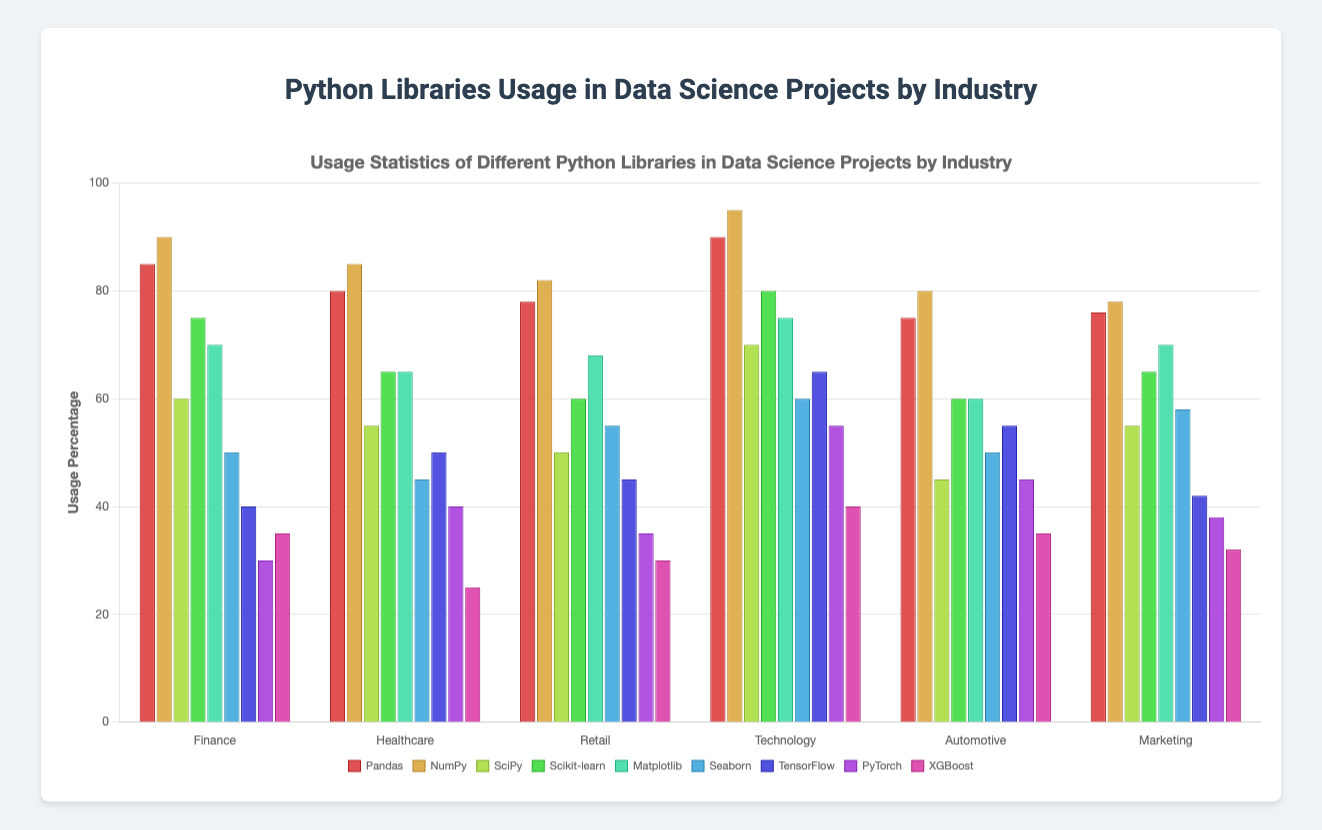Which industry has the highest usage of Pandas? Look at the Pandas usage bar for all industries. Technology has the highest bar at 90%.
Answer: Technology By how much does TensorFlow usage in Healthcare exceed that in Finance? TensorFlow usage in Healthcare is 50%, while in Finance it is 40%. Subtract 40% from 50% to find the difference.
Answer: 10% Compare the usage of Scikit-learn and Matplotlib in the Retail industry. Which one is higher? Refer to the bars for Scikit-learn and Matplotlib in Retail. Scikit-learn is at 60%, and Matplotlib is at 68%. 68% > 60%, so Matplotlib has higher usage.
Answer: Matplotlib What is the average usage of XGBoost across all industries? Add the XGBoost usage in each industry: 35% + 25% + 30% + 40% + 35% + 32%. There are 6 industries: (35+25+30+40+35+32)/6 = 197/6 = 32.83%
Answer: 32.83% Which industry has the lowest usage of PyTorch? Look at the PyTorch usage bars for all industries. Finance has the lowest bar at 30%.
Answer: Finance Which Python library has the highest overall usage in Technology? Compare the bars for all libraries in the Technology industry. NumPy is the highest at 95%.
Answer: NumPy What is the difference in Seaborn usage between Marketing and Healthcare? Seaborn usage in Marketing is 58%, and in Healthcare is 45%. Subtract 45% from 58% to find the difference.
Answer: 13% Identify the industry with the least consistent distribution of library usage. Review the variation lengths of bars within each industry. The most inconsistent has the biggest spread between the highest and lowest values. Finance has large differences (e.g., NumPy 90%, PyTorch 30%).
Answer: Finance Calculate the average usage for Matplotlib across Finance, Automotive, and Marketing industries. Add Matplotlib usage in these industries: 70% (Finance) + 60% (Automotive) + 70% (Marketing). There are 3 industries: (70+60+70)/3 = 200/3 = 66.67%
Answer: 66.67% 